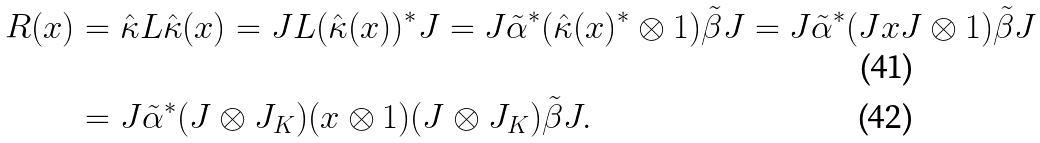<formula> <loc_0><loc_0><loc_500><loc_500>R ( x ) & = \hat { \kappa } L \hat { \kappa } ( x ) = J L ( \hat { \kappa } ( x ) ) ^ { * } J = J \tilde { \alpha } ^ { * } ( \hat { \kappa } ( x ) ^ { * } \otimes 1 ) \tilde { \beta } J = J \tilde { \alpha } ^ { * } ( J x J \otimes 1 ) \tilde { \beta } J \\ & = J \tilde { \alpha } ^ { * } ( J \otimes J _ { K } ) ( x \otimes 1 ) ( J \otimes J _ { K } ) \tilde { \beta } J .</formula> 